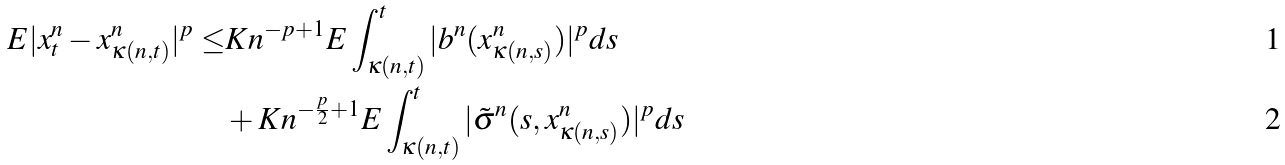<formula> <loc_0><loc_0><loc_500><loc_500>E | x _ { t } ^ { n } - x _ { \kappa ( n , t ) } ^ { n } | ^ { p } \leq & K n ^ { - p + 1 } E \int _ { \kappa ( n , t ) } ^ { t } | b ^ { n } ( x _ { \kappa ( n , s ) } ^ { n } ) | ^ { p } d s \\ & + K n ^ { - \frac { p } { 2 } + 1 } E \int _ { \kappa ( n , t ) } ^ { t } | \tilde { \sigma } ^ { n } ( s , x _ { \kappa ( n , s ) } ^ { n } ) | ^ { p } d s</formula> 